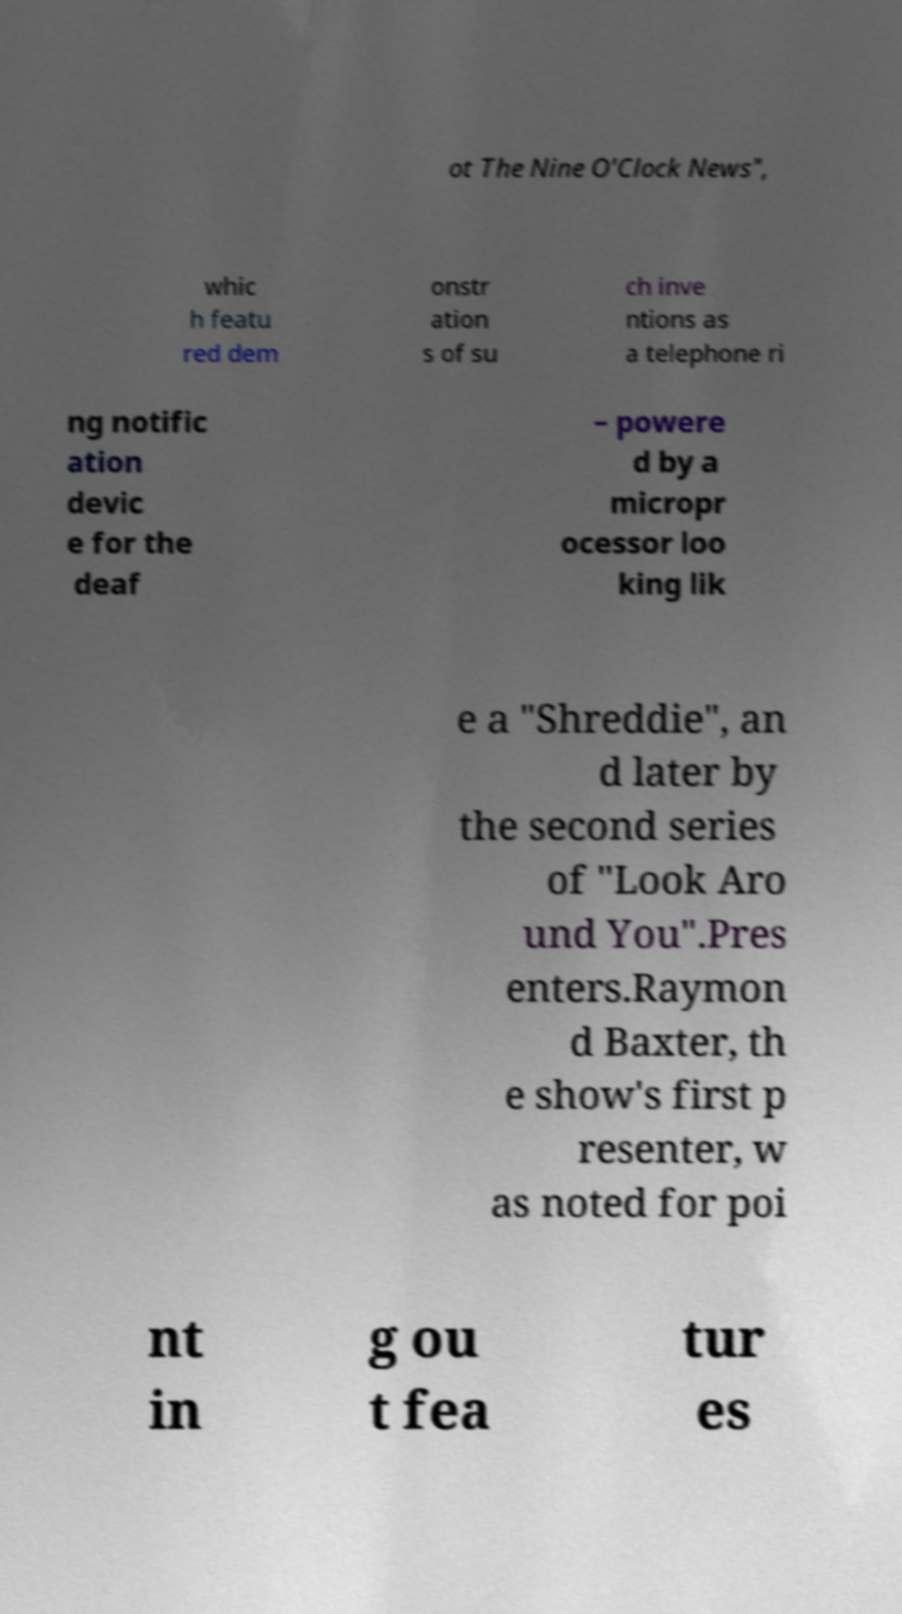Could you assist in decoding the text presented in this image and type it out clearly? ot The Nine O'Clock News", whic h featu red dem onstr ation s of su ch inve ntions as a telephone ri ng notific ation devic e for the deaf – powere d by a micropr ocessor loo king lik e a "Shreddie", an d later by the second series of "Look Aro und You".Pres enters.Raymon d Baxter, th e show's first p resenter, w as noted for poi nt in g ou t fea tur es 